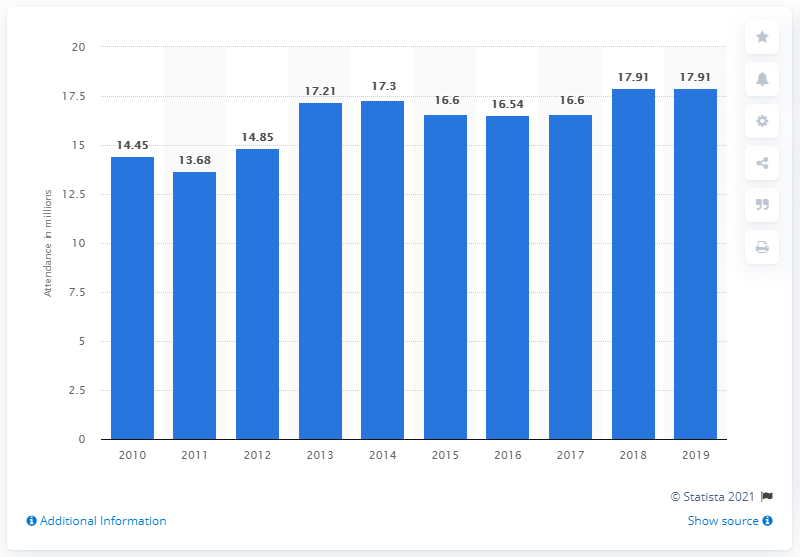Highlight a few significant elements in this photo. In 2019, a total of 17,910 visitors visited Tokyo Disneyland. 